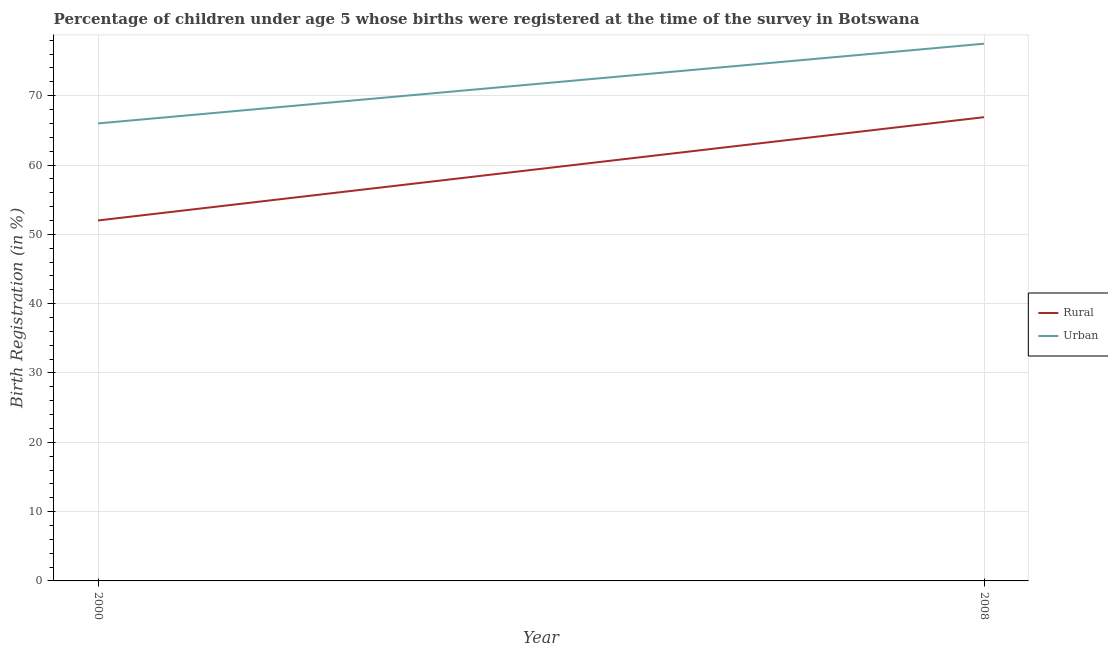How many different coloured lines are there?
Offer a terse response. 2. Does the line corresponding to urban birth registration intersect with the line corresponding to rural birth registration?
Your answer should be very brief. No. Is the number of lines equal to the number of legend labels?
Provide a succinct answer. Yes. What is the rural birth registration in 2008?
Your answer should be compact. 66.9. Across all years, what is the maximum rural birth registration?
Ensure brevity in your answer.  66.9. In which year was the urban birth registration maximum?
Make the answer very short. 2008. In which year was the urban birth registration minimum?
Ensure brevity in your answer.  2000. What is the total rural birth registration in the graph?
Provide a short and direct response. 118.9. What is the difference between the urban birth registration in 2000 and that in 2008?
Your response must be concise. -11.5. What is the difference between the urban birth registration in 2000 and the rural birth registration in 2008?
Provide a succinct answer. -0.9. What is the average urban birth registration per year?
Provide a short and direct response. 71.75. In the year 2008, what is the difference between the rural birth registration and urban birth registration?
Make the answer very short. -10.6. What is the ratio of the rural birth registration in 2000 to that in 2008?
Offer a very short reply. 0.78. Is the rural birth registration in 2000 less than that in 2008?
Provide a succinct answer. Yes. In how many years, is the urban birth registration greater than the average urban birth registration taken over all years?
Offer a very short reply. 1. Does the rural birth registration monotonically increase over the years?
Keep it short and to the point. Yes. How many years are there in the graph?
Provide a succinct answer. 2. Are the values on the major ticks of Y-axis written in scientific E-notation?
Make the answer very short. No. Does the graph contain any zero values?
Provide a short and direct response. No. Does the graph contain grids?
Offer a terse response. Yes. Where does the legend appear in the graph?
Ensure brevity in your answer.  Center right. How many legend labels are there?
Your answer should be compact. 2. What is the title of the graph?
Your answer should be compact. Percentage of children under age 5 whose births were registered at the time of the survey in Botswana. Does "Not attending school" appear as one of the legend labels in the graph?
Your answer should be very brief. No. What is the label or title of the Y-axis?
Give a very brief answer. Birth Registration (in %). What is the Birth Registration (in %) in Rural in 2000?
Offer a terse response. 52. What is the Birth Registration (in %) of Urban in 2000?
Your answer should be very brief. 66. What is the Birth Registration (in %) of Rural in 2008?
Keep it short and to the point. 66.9. What is the Birth Registration (in %) of Urban in 2008?
Your answer should be compact. 77.5. Across all years, what is the maximum Birth Registration (in %) in Rural?
Give a very brief answer. 66.9. Across all years, what is the maximum Birth Registration (in %) of Urban?
Your answer should be compact. 77.5. Across all years, what is the minimum Birth Registration (in %) in Rural?
Provide a succinct answer. 52. What is the total Birth Registration (in %) of Rural in the graph?
Give a very brief answer. 118.9. What is the total Birth Registration (in %) in Urban in the graph?
Provide a short and direct response. 143.5. What is the difference between the Birth Registration (in %) in Rural in 2000 and that in 2008?
Give a very brief answer. -14.9. What is the difference between the Birth Registration (in %) of Urban in 2000 and that in 2008?
Provide a succinct answer. -11.5. What is the difference between the Birth Registration (in %) in Rural in 2000 and the Birth Registration (in %) in Urban in 2008?
Ensure brevity in your answer.  -25.5. What is the average Birth Registration (in %) in Rural per year?
Keep it short and to the point. 59.45. What is the average Birth Registration (in %) in Urban per year?
Your response must be concise. 71.75. What is the ratio of the Birth Registration (in %) of Rural in 2000 to that in 2008?
Offer a terse response. 0.78. What is the ratio of the Birth Registration (in %) of Urban in 2000 to that in 2008?
Your response must be concise. 0.85. What is the difference between the highest and the second highest Birth Registration (in %) of Rural?
Give a very brief answer. 14.9. 